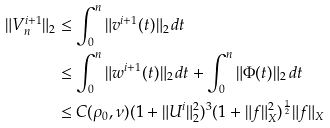Convert formula to latex. <formula><loc_0><loc_0><loc_500><loc_500>\| V _ { n } ^ { i + 1 } \| _ { 2 } & \leq \int _ { 0 } ^ { n } \| v ^ { i + 1 } ( t ) \| _ { 2 } \, d t \\ & \leq \int _ { 0 } ^ { n } \| w ^ { i + 1 } ( t ) \| _ { 2 } \, d t + \int _ { 0 } ^ { n } \| \Phi ( t ) \| _ { 2 } \, d t \\ & \leq C ( \rho _ { 0 } , \nu ) ( 1 + \| U ^ { i } \| _ { 2 } ^ { 2 } ) ^ { 3 } ( 1 + \| f \| _ { X } ^ { 2 } ) ^ { \frac { 1 } { 2 } } \| f \| _ { X }</formula> 